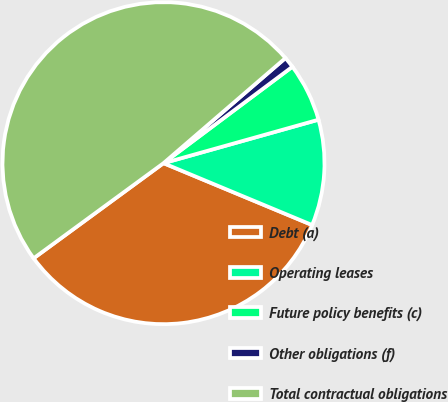Convert chart to OTSL. <chart><loc_0><loc_0><loc_500><loc_500><pie_chart><fcel>Debt (a)<fcel>Operating leases<fcel>Future policy benefits (c)<fcel>Other obligations (f)<fcel>Total contractual obligations<nl><fcel>33.66%<fcel>10.63%<fcel>5.87%<fcel>1.1%<fcel>48.74%<nl></chart> 